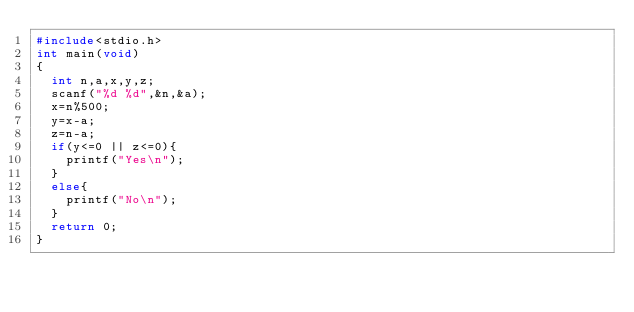Convert code to text. <code><loc_0><loc_0><loc_500><loc_500><_C++_>#include<stdio.h>
int main(void)
{
	int n,a,x,y,z;
	scanf("%d %d",&n,&a);
	x=n%500;
	y=x-a;
	z=n-a;
	if(y<=0 || z<=0){
		printf("Yes\n");
	}
	else{
		printf("No\n");
	}
	return 0;
}</code> 